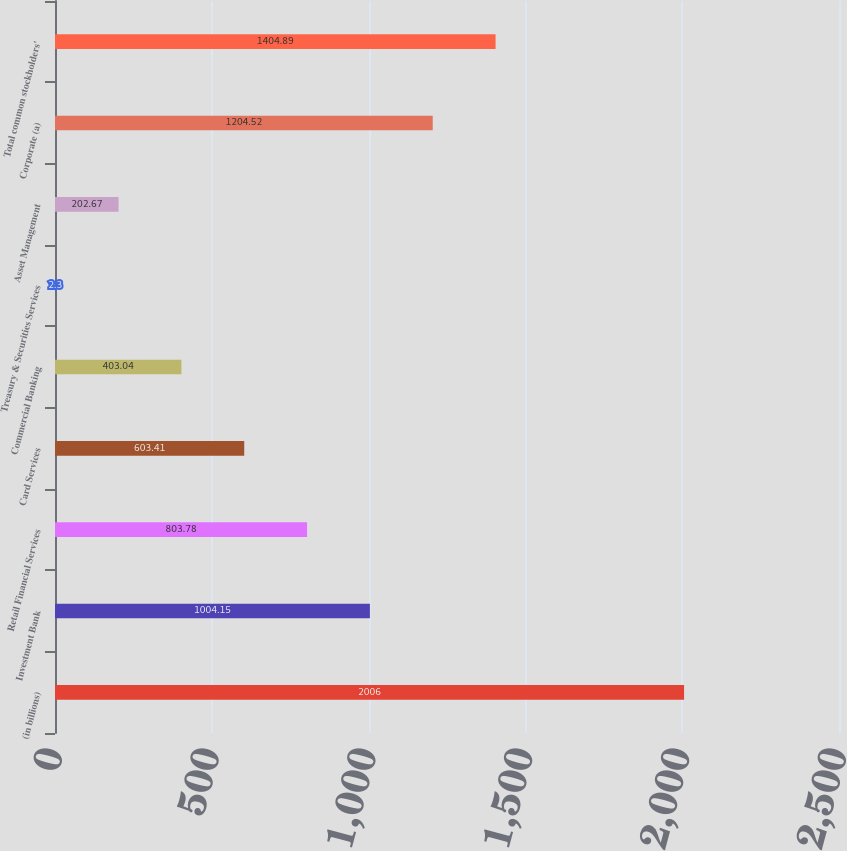<chart> <loc_0><loc_0><loc_500><loc_500><bar_chart><fcel>(in billions)<fcel>Investment Bank<fcel>Retail Financial Services<fcel>Card Services<fcel>Commercial Banking<fcel>Treasury & Securities Services<fcel>Asset Management<fcel>Corporate (a)<fcel>Total common stockholders'<nl><fcel>2006<fcel>1004.15<fcel>803.78<fcel>603.41<fcel>403.04<fcel>2.3<fcel>202.67<fcel>1204.52<fcel>1404.89<nl></chart> 